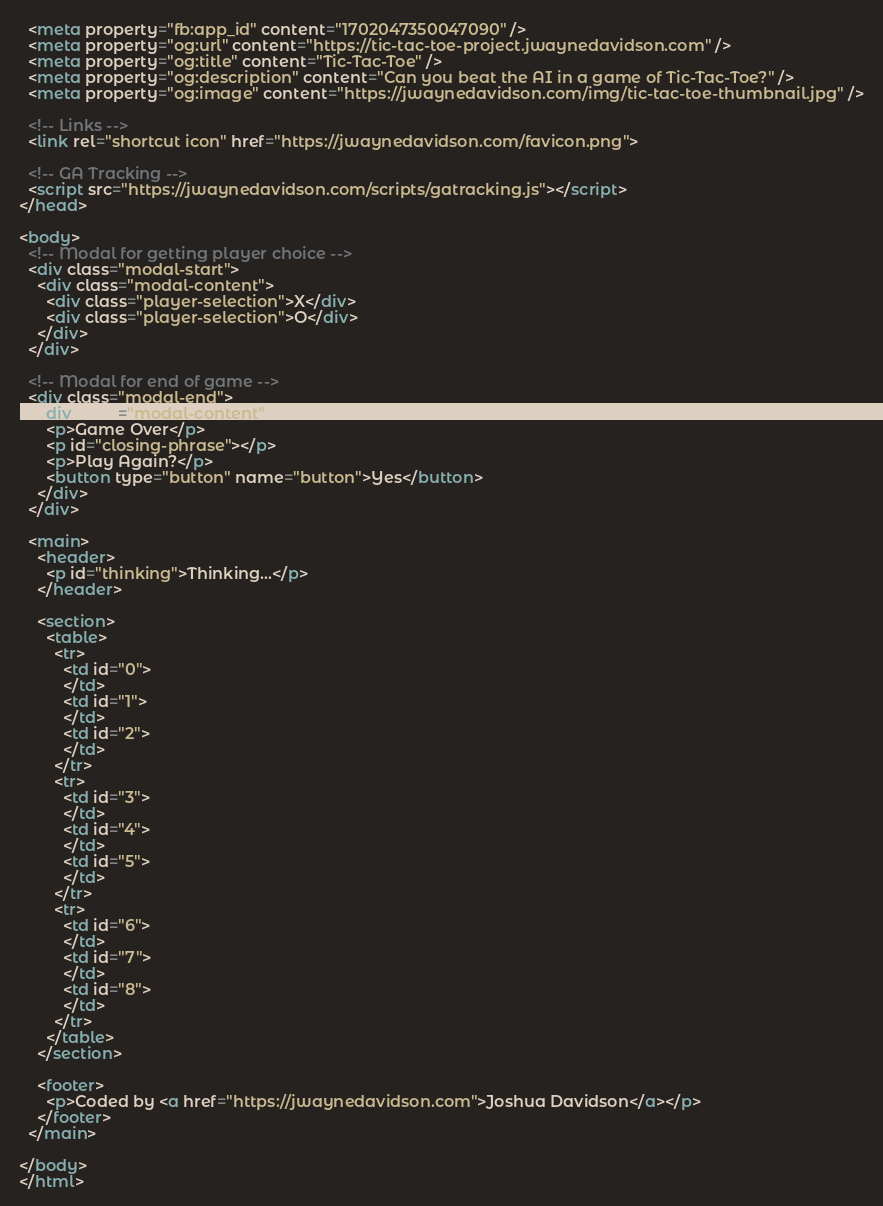Convert code to text. <code><loc_0><loc_0><loc_500><loc_500><_HTML_>  <meta property="fb:app_id" content="1702047350047090" />
  <meta property="og:url" content="https://tic-tac-toe-project.jwaynedavidson.com" />
  <meta property="og:title" content="Tic-Tac-Toe" />
  <meta property="og:description" content="Can you beat the AI in a game of Tic-Tac-Toe?" />
  <meta property="og:image" content="https://jwaynedavidson.com/img/tic-tac-toe-thumbnail.jpg" />

  <!-- Links -->
  <link rel="shortcut icon" href="https://jwaynedavidson.com/favicon.png">

  <!-- GA Tracking -->
  <script src="https://jwaynedavidson.com/scripts/gatracking.js"></script>
</head>

<body>
  <!-- Modal for getting player choice -->
  <div class="modal-start">
    <div class="modal-content">
      <div class="player-selection">X</div>
      <div class="player-selection">O</div>
    </div>
  </div>

  <!-- Modal for end of game -->
  <div class="modal-end">
    <div class="modal-content">
      <p>Game Over</p>
      <p id="closing-phrase"></p>
      <p>Play Again?</p>
      <button type="button" name="button">Yes</button>
    </div>
  </div>

  <main>
    <header>
      <p id="thinking">Thinking...</p>
    </header>

    <section>
      <table>
        <tr>
          <td id="0">
          </td>
          <td id="1">
          </td>
          <td id="2">
          </td>
        </tr>
        <tr>
          <td id="3">
          </td>
          <td id="4">
          </td>
          <td id="5">
          </td>
        </tr>
        <tr>
          <td id="6">
          </td>
          <td id="7">
          </td>
          <td id="8">
          </td>
        </tr>
      </table>
    </section>

    <footer>
      <p>Coded by <a href="https://jwaynedavidson.com">Joshua Davidson</a></p>
    </footer>
  </main>

</body>
</html>
</code> 